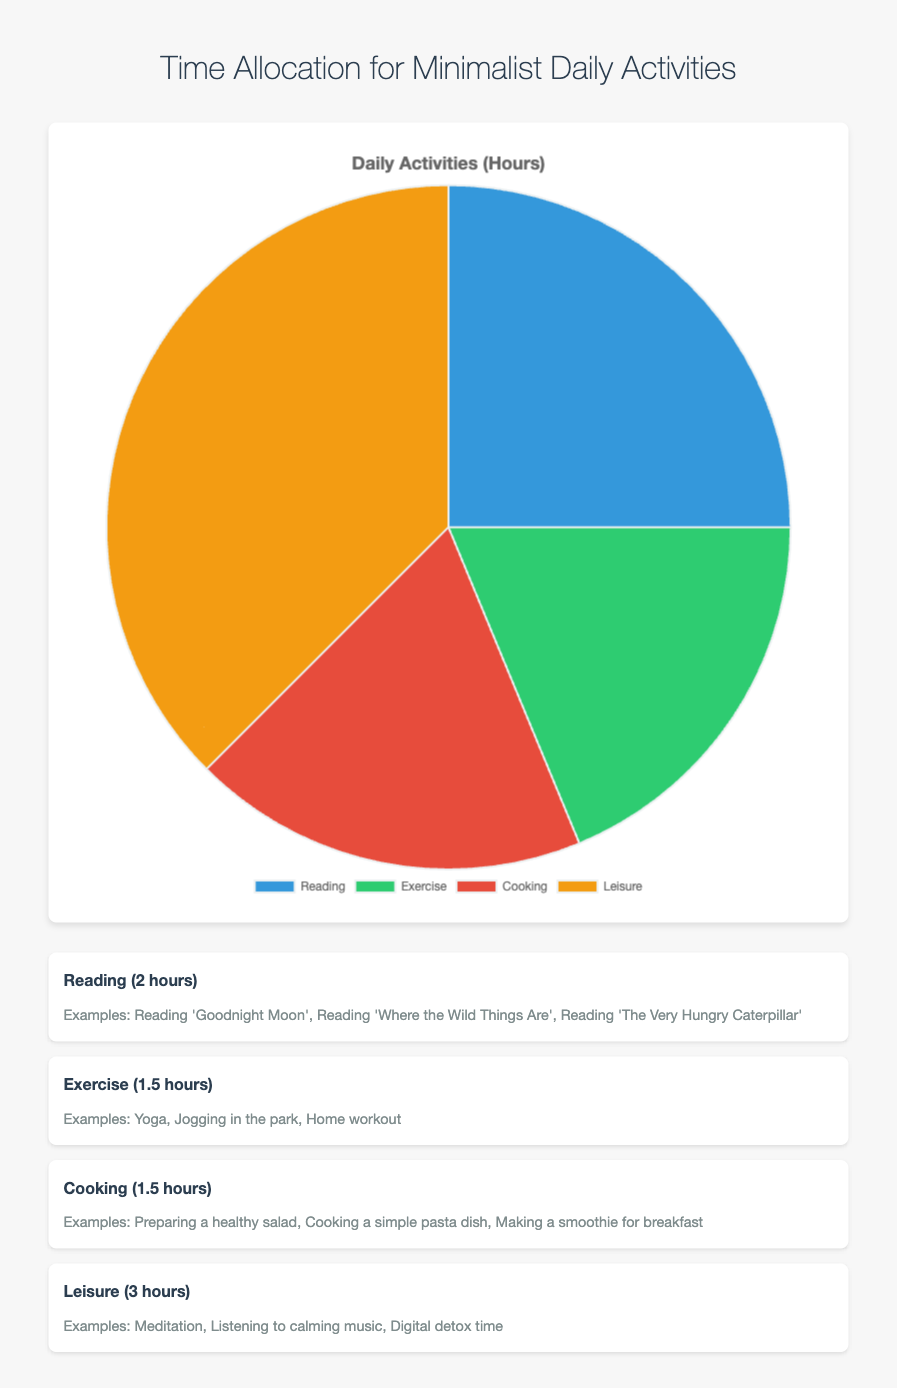Which activity takes up the most time in the day? By looking at the pie chart, identify the section with the largest visual proportion, which corresponds to the most time-consuming activity.
Answer: Leisure How many hours are allocated to 'Reading' and 'Cooking' combined? Sum the hours spent on 'Reading' (2 hours) and 'Cooking' (1.5 hours). 2 + 1.5 = 3.5
Answer: 3.5 Is the time spent on 'Exercise' equal to the time spent on 'Cooking'? Compare the hours spent on 'Exercise' (1.5) to the hours spent on 'Cooking' (1.5). 1.5 = 1.5
Answer: Yes What percentage of the day is spent on 'Reading'? Calculate the percentage by taking the hours spent reading (2) and dividing it by the total hours in a day allocated to activities (Reading: 2, Exercise: 1.5, Cooking: 1.5, Leisure: 3). Total hours = 8; (2/8) * 100% = 25%
Answer: 25% Which activities take up an equal amount of time each day? Identify activities with the same number of hours. Exercise and Cooking both have 1.5 hours each.
Answer: Exercise, Cooking What is the total time spent on 'Exercise' and 'Leisure'? Add the hours allocated to 'Exercise' (1.5 hours) and 'Leisure' (3 hours). 1.5 + 3 = 4.5
Answer: 4.5 Compare the time allocation between 'Reading' and 'Exercise'. Which one takes less time? Identify the hours spent on each activity: 'Reading' is 2 hours and 'Exercise' is 1.5 hours. Compare them to find that 'Exercise' takes less time.
Answer: Exercise How does the allocated time for 'Leisure' compare to the total time spent on 'Cooking' and 'Exercise' combined? Sum the hours for 'Cooking' (1.5 hours) and 'Exercise' (1.5 hours). Compare this to 'Leisure' (3 hours). 1.5 + 1.5 = 3; 3 = 3
Answer: Equal What color represents the activity with the least allocated time? Identify the colors on the pie chart and the time allocated to each section. The section with the least time is 'Exercise' and 'Cooking' (both 1.5 hours). Refer to the chart to find the color corresponding to 'Exercise' (green) and 'Cooking' (red).
Answer: Green, Red 